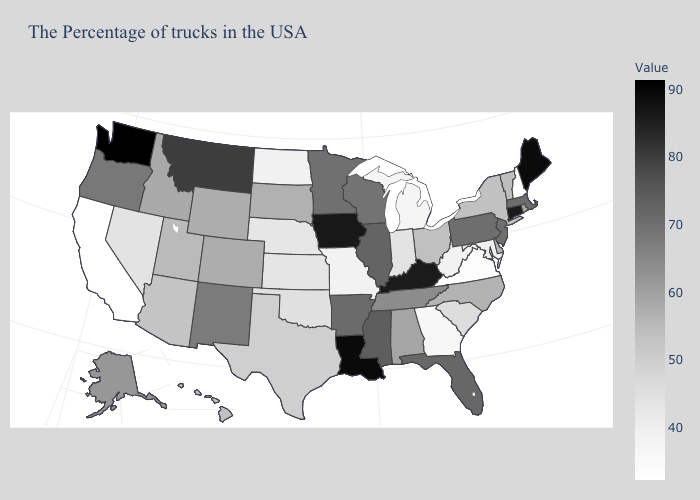Among the states that border New Jersey , which have the lowest value?
Give a very brief answer. New York. Which states have the lowest value in the USA?
Give a very brief answer. New Hampshire. Which states have the lowest value in the South?
Concise answer only. Virginia. Which states have the lowest value in the USA?
Write a very short answer. New Hampshire. Among the states that border Oklahoma , does New Mexico have the highest value?
Give a very brief answer. No. Which states hav the highest value in the South?
Concise answer only. Louisiana. 